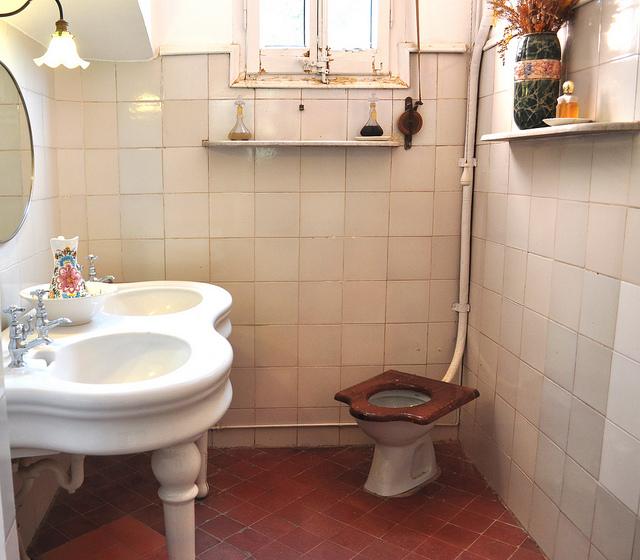What type of room is this?
Give a very brief answer. Bathroom. What color are the pipes in the photo?
Quick response, please. White. How many sinks are there?
Be succinct. 2. What material is the toilet seat made of?
Give a very brief answer. Wood. 